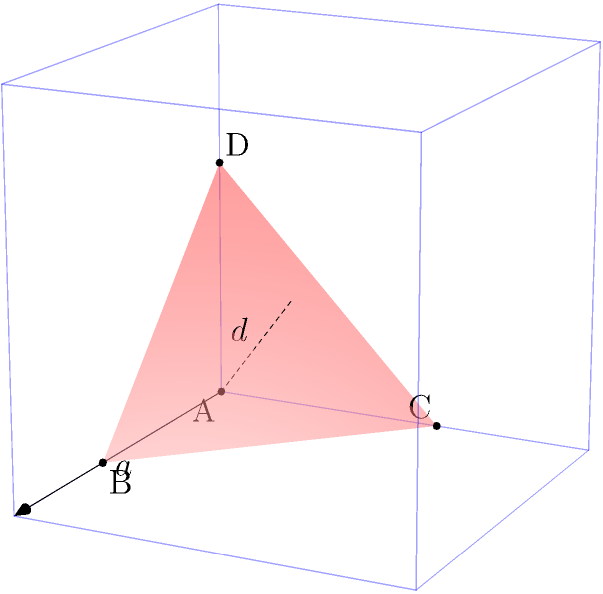As an HR director who often applies psychological principles, you're tasked with creating a team-building exercise involving spatial reasoning. You decide to use a geometric puzzle based on cutting a corner off a cube. If a cube has an edge length of $a$ and a corner is cut off at a distance $d$ from the corner along each edge, what is the volume of the resulting tetrahedron in terms of $a$ and $d$? Let's approach this step-by-step:

1) First, we need to understand what we're looking at. The tetrahedron ABCD is formed by cutting off the corner of the cube.

2) The volume of a tetrahedron is given by the formula:
   $$V = \frac{1}{3} \times \text{base area} \times \text{height}$$

3) In this case, we can choose any face as the base. Let's choose the triangle BCD as the base.

4) The area of triangle BCD:
   - Each side of this triangle has length $d\sqrt{2}$ (because it's the diagonal of a square with side $d$)
   - Area of an equilateral triangle = $\frac{\sqrt{3}}{4}s^2$, where $s$ is the side length
   - So, area of BCD = $\frac{\sqrt{3}}{4}(d\sqrt{2})^2 = \frac{\sqrt{3}}{2}d^2$

5) The height of the tetrahedron:
   - This is the perpendicular distance from point A to the plane BCD
   - It can be calculated as $d\sqrt{3}$ (the diagonal of a cube with side $d$)

6) Now we can calculate the volume:
   $$V = \frac{1}{3} \times \frac{\sqrt{3}}{2}d^2 \times d\sqrt{3} = \frac{1}{2}d^3$$

7) However, we need to express this in terms of $a$ as well. We can see that $a-d$ is the length of the edge of the cube that remains after cutting.
   So, $d = a - (a-d) = a - (a-d)$

8) Solving this equation:
   $d = a - a + d$
   $d = d$

   This means our original expression for volume is already in terms of both $a$ and $d$.

Therefore, the volume of the tetrahedron is $\frac{1}{2}d^3$.
Answer: $\frac{1}{2}d^3$ 